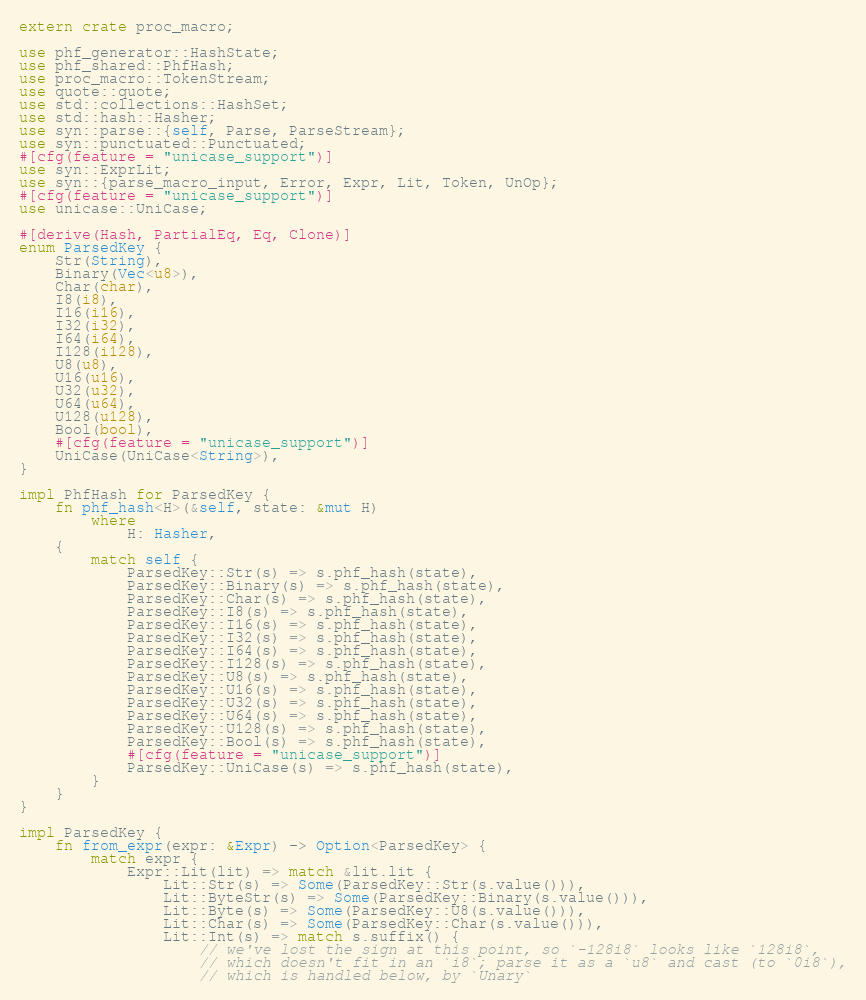<code> <loc_0><loc_0><loc_500><loc_500><_Rust_>extern crate proc_macro;

use phf_generator::HashState;
use phf_shared::PhfHash;
use proc_macro::TokenStream;
use quote::quote;
use std::collections::HashSet;
use std::hash::Hasher;
use syn::parse::{self, Parse, ParseStream};
use syn::punctuated::Punctuated;
#[cfg(feature = "unicase_support")]
use syn::ExprLit;
use syn::{parse_macro_input, Error, Expr, Lit, Token, UnOp};
#[cfg(feature = "unicase_support")]
use unicase::UniCase;

#[derive(Hash, PartialEq, Eq, Clone)]
enum ParsedKey {
    Str(String),
    Binary(Vec<u8>),
    Char(char),
    I8(i8),
    I16(i16),
    I32(i32),
    I64(i64),
    I128(i128),
    U8(u8),
    U16(u16),
    U32(u32),
    U64(u64),
    U128(u128),
    Bool(bool),
    #[cfg(feature = "unicase_support")]
    UniCase(UniCase<String>),
}

impl PhfHash for ParsedKey {
    fn phf_hash<H>(&self, state: &mut H)
        where
            H: Hasher,
    {
        match self {
            ParsedKey::Str(s) => s.phf_hash(state),
            ParsedKey::Binary(s) => s.phf_hash(state),
            ParsedKey::Char(s) => s.phf_hash(state),
            ParsedKey::I8(s) => s.phf_hash(state),
            ParsedKey::I16(s) => s.phf_hash(state),
            ParsedKey::I32(s) => s.phf_hash(state),
            ParsedKey::I64(s) => s.phf_hash(state),
            ParsedKey::I128(s) => s.phf_hash(state),
            ParsedKey::U8(s) => s.phf_hash(state),
            ParsedKey::U16(s) => s.phf_hash(state),
            ParsedKey::U32(s) => s.phf_hash(state),
            ParsedKey::U64(s) => s.phf_hash(state),
            ParsedKey::U128(s) => s.phf_hash(state),
            ParsedKey::Bool(s) => s.phf_hash(state),
            #[cfg(feature = "unicase_support")]
            ParsedKey::UniCase(s) => s.phf_hash(state),
        }
    }
}

impl ParsedKey {
    fn from_expr(expr: &Expr) -> Option<ParsedKey> {
        match expr {
            Expr::Lit(lit) => match &lit.lit {
                Lit::Str(s) => Some(ParsedKey::Str(s.value())),
                Lit::ByteStr(s) => Some(ParsedKey::Binary(s.value())),
                Lit::Byte(s) => Some(ParsedKey::U8(s.value())),
                Lit::Char(s) => Some(ParsedKey::Char(s.value())),
                Lit::Int(s) => match s.suffix() {
                    // we've lost the sign at this point, so `-128i8` looks like `128i8`,
                    // which doesn't fit in an `i8`; parse it as a `u8` and cast (to `0i8`),
                    // which is handled below, by `Unary`</code> 